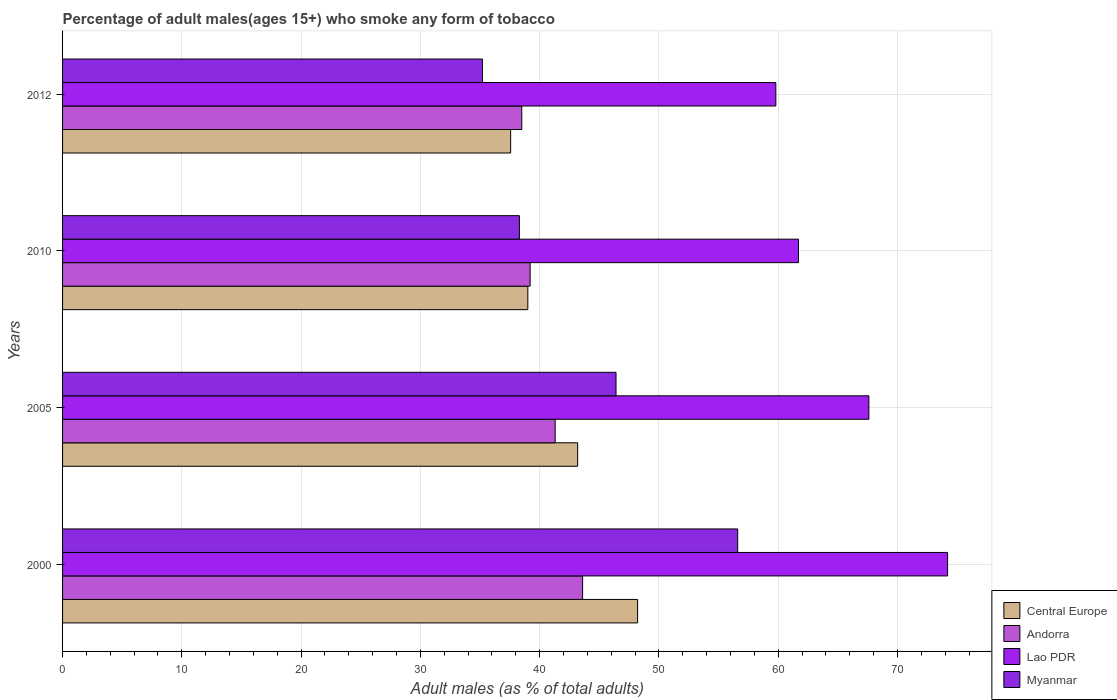How many different coloured bars are there?
Keep it short and to the point. 4. How many groups of bars are there?
Keep it short and to the point. 4. Are the number of bars per tick equal to the number of legend labels?
Offer a very short reply. Yes. How many bars are there on the 4th tick from the top?
Provide a succinct answer. 4. How many bars are there on the 1st tick from the bottom?
Offer a very short reply. 4. In how many cases, is the number of bars for a given year not equal to the number of legend labels?
Your response must be concise. 0. What is the percentage of adult males who smoke in Andorra in 2010?
Your response must be concise. 39.2. Across all years, what is the maximum percentage of adult males who smoke in Lao PDR?
Provide a succinct answer. 74.2. Across all years, what is the minimum percentage of adult males who smoke in Andorra?
Provide a succinct answer. 38.5. In which year was the percentage of adult males who smoke in Andorra minimum?
Provide a succinct answer. 2012. What is the total percentage of adult males who smoke in Central Europe in the graph?
Offer a very short reply. 167.97. What is the difference between the percentage of adult males who smoke in Central Europe in 2005 and that in 2010?
Your answer should be very brief. 4.18. What is the average percentage of adult males who smoke in Andorra per year?
Offer a terse response. 40.65. In the year 2012, what is the difference between the percentage of adult males who smoke in Myanmar and percentage of adult males who smoke in Lao PDR?
Keep it short and to the point. -24.6. In how many years, is the percentage of adult males who smoke in Andorra greater than 66 %?
Keep it short and to the point. 0. What is the ratio of the percentage of adult males who smoke in Lao PDR in 2000 to that in 2010?
Provide a succinct answer. 1.2. Is the percentage of adult males who smoke in Andorra in 2005 less than that in 2012?
Make the answer very short. No. What is the difference between the highest and the second highest percentage of adult males who smoke in Myanmar?
Your answer should be very brief. 10.2. What is the difference between the highest and the lowest percentage of adult males who smoke in Lao PDR?
Offer a terse response. 14.4. Is the sum of the percentage of adult males who smoke in Andorra in 2000 and 2005 greater than the maximum percentage of adult males who smoke in Myanmar across all years?
Make the answer very short. Yes. Is it the case that in every year, the sum of the percentage of adult males who smoke in Lao PDR and percentage of adult males who smoke in Myanmar is greater than the sum of percentage of adult males who smoke in Central Europe and percentage of adult males who smoke in Andorra?
Provide a short and direct response. No. What does the 2nd bar from the top in 2012 represents?
Give a very brief answer. Lao PDR. What does the 4th bar from the bottom in 2012 represents?
Offer a very short reply. Myanmar. Is it the case that in every year, the sum of the percentage of adult males who smoke in Myanmar and percentage of adult males who smoke in Lao PDR is greater than the percentage of adult males who smoke in Andorra?
Provide a short and direct response. Yes. Are all the bars in the graph horizontal?
Give a very brief answer. Yes. What is the difference between two consecutive major ticks on the X-axis?
Make the answer very short. 10. Are the values on the major ticks of X-axis written in scientific E-notation?
Offer a terse response. No. Does the graph contain grids?
Make the answer very short. Yes. What is the title of the graph?
Offer a very short reply. Percentage of adult males(ages 15+) who smoke any form of tobacco. What is the label or title of the X-axis?
Keep it short and to the point. Adult males (as % of total adults). What is the label or title of the Y-axis?
Your answer should be very brief. Years. What is the Adult males (as % of total adults) of Central Europe in 2000?
Make the answer very short. 48.21. What is the Adult males (as % of total adults) in Andorra in 2000?
Keep it short and to the point. 43.6. What is the Adult males (as % of total adults) of Lao PDR in 2000?
Your answer should be very brief. 74.2. What is the Adult males (as % of total adults) of Myanmar in 2000?
Provide a short and direct response. 56.6. What is the Adult males (as % of total adults) of Central Europe in 2005?
Your answer should be compact. 43.18. What is the Adult males (as % of total adults) in Andorra in 2005?
Make the answer very short. 41.3. What is the Adult males (as % of total adults) of Lao PDR in 2005?
Make the answer very short. 67.6. What is the Adult males (as % of total adults) in Myanmar in 2005?
Offer a very short reply. 46.4. What is the Adult males (as % of total adults) in Central Europe in 2010?
Keep it short and to the point. 39.01. What is the Adult males (as % of total adults) of Andorra in 2010?
Ensure brevity in your answer.  39.2. What is the Adult males (as % of total adults) in Lao PDR in 2010?
Ensure brevity in your answer.  61.7. What is the Adult males (as % of total adults) in Myanmar in 2010?
Make the answer very short. 38.3. What is the Adult males (as % of total adults) in Central Europe in 2012?
Ensure brevity in your answer.  37.57. What is the Adult males (as % of total adults) of Andorra in 2012?
Provide a short and direct response. 38.5. What is the Adult males (as % of total adults) of Lao PDR in 2012?
Offer a terse response. 59.8. What is the Adult males (as % of total adults) in Myanmar in 2012?
Give a very brief answer. 35.2. Across all years, what is the maximum Adult males (as % of total adults) in Central Europe?
Ensure brevity in your answer.  48.21. Across all years, what is the maximum Adult males (as % of total adults) of Andorra?
Offer a terse response. 43.6. Across all years, what is the maximum Adult males (as % of total adults) of Lao PDR?
Give a very brief answer. 74.2. Across all years, what is the maximum Adult males (as % of total adults) in Myanmar?
Give a very brief answer. 56.6. Across all years, what is the minimum Adult males (as % of total adults) in Central Europe?
Make the answer very short. 37.57. Across all years, what is the minimum Adult males (as % of total adults) of Andorra?
Your answer should be compact. 38.5. Across all years, what is the minimum Adult males (as % of total adults) of Lao PDR?
Make the answer very short. 59.8. Across all years, what is the minimum Adult males (as % of total adults) of Myanmar?
Give a very brief answer. 35.2. What is the total Adult males (as % of total adults) in Central Europe in the graph?
Your answer should be very brief. 167.97. What is the total Adult males (as % of total adults) in Andorra in the graph?
Give a very brief answer. 162.6. What is the total Adult males (as % of total adults) of Lao PDR in the graph?
Your answer should be compact. 263.3. What is the total Adult males (as % of total adults) in Myanmar in the graph?
Give a very brief answer. 176.5. What is the difference between the Adult males (as % of total adults) in Central Europe in 2000 and that in 2005?
Your answer should be very brief. 5.02. What is the difference between the Adult males (as % of total adults) in Andorra in 2000 and that in 2005?
Your answer should be compact. 2.3. What is the difference between the Adult males (as % of total adults) in Myanmar in 2000 and that in 2005?
Make the answer very short. 10.2. What is the difference between the Adult males (as % of total adults) in Central Europe in 2000 and that in 2010?
Offer a terse response. 9.2. What is the difference between the Adult males (as % of total adults) in Central Europe in 2000 and that in 2012?
Keep it short and to the point. 10.64. What is the difference between the Adult males (as % of total adults) of Myanmar in 2000 and that in 2012?
Provide a succinct answer. 21.4. What is the difference between the Adult males (as % of total adults) in Central Europe in 2005 and that in 2010?
Offer a very short reply. 4.18. What is the difference between the Adult males (as % of total adults) of Lao PDR in 2005 and that in 2010?
Offer a terse response. 5.9. What is the difference between the Adult males (as % of total adults) in Myanmar in 2005 and that in 2010?
Provide a short and direct response. 8.1. What is the difference between the Adult males (as % of total adults) of Central Europe in 2005 and that in 2012?
Your answer should be compact. 5.62. What is the difference between the Adult males (as % of total adults) in Andorra in 2005 and that in 2012?
Your answer should be very brief. 2.8. What is the difference between the Adult males (as % of total adults) of Central Europe in 2010 and that in 2012?
Ensure brevity in your answer.  1.44. What is the difference between the Adult males (as % of total adults) in Andorra in 2010 and that in 2012?
Your answer should be very brief. 0.7. What is the difference between the Adult males (as % of total adults) in Lao PDR in 2010 and that in 2012?
Give a very brief answer. 1.9. What is the difference between the Adult males (as % of total adults) in Central Europe in 2000 and the Adult males (as % of total adults) in Andorra in 2005?
Offer a very short reply. 6.91. What is the difference between the Adult males (as % of total adults) in Central Europe in 2000 and the Adult males (as % of total adults) in Lao PDR in 2005?
Make the answer very short. -19.39. What is the difference between the Adult males (as % of total adults) of Central Europe in 2000 and the Adult males (as % of total adults) of Myanmar in 2005?
Offer a terse response. 1.81. What is the difference between the Adult males (as % of total adults) in Andorra in 2000 and the Adult males (as % of total adults) in Lao PDR in 2005?
Ensure brevity in your answer.  -24. What is the difference between the Adult males (as % of total adults) of Andorra in 2000 and the Adult males (as % of total adults) of Myanmar in 2005?
Ensure brevity in your answer.  -2.8. What is the difference between the Adult males (as % of total adults) of Lao PDR in 2000 and the Adult males (as % of total adults) of Myanmar in 2005?
Your answer should be very brief. 27.8. What is the difference between the Adult males (as % of total adults) in Central Europe in 2000 and the Adult males (as % of total adults) in Andorra in 2010?
Provide a succinct answer. 9.01. What is the difference between the Adult males (as % of total adults) in Central Europe in 2000 and the Adult males (as % of total adults) in Lao PDR in 2010?
Offer a very short reply. -13.49. What is the difference between the Adult males (as % of total adults) in Central Europe in 2000 and the Adult males (as % of total adults) in Myanmar in 2010?
Your response must be concise. 9.91. What is the difference between the Adult males (as % of total adults) of Andorra in 2000 and the Adult males (as % of total adults) of Lao PDR in 2010?
Your answer should be very brief. -18.1. What is the difference between the Adult males (as % of total adults) in Lao PDR in 2000 and the Adult males (as % of total adults) in Myanmar in 2010?
Ensure brevity in your answer.  35.9. What is the difference between the Adult males (as % of total adults) in Central Europe in 2000 and the Adult males (as % of total adults) in Andorra in 2012?
Offer a terse response. 9.71. What is the difference between the Adult males (as % of total adults) in Central Europe in 2000 and the Adult males (as % of total adults) in Lao PDR in 2012?
Your answer should be compact. -11.59. What is the difference between the Adult males (as % of total adults) in Central Europe in 2000 and the Adult males (as % of total adults) in Myanmar in 2012?
Your answer should be compact. 13.01. What is the difference between the Adult males (as % of total adults) in Andorra in 2000 and the Adult males (as % of total adults) in Lao PDR in 2012?
Offer a terse response. -16.2. What is the difference between the Adult males (as % of total adults) of Andorra in 2000 and the Adult males (as % of total adults) of Myanmar in 2012?
Give a very brief answer. 8.4. What is the difference between the Adult males (as % of total adults) of Central Europe in 2005 and the Adult males (as % of total adults) of Andorra in 2010?
Your answer should be compact. 3.98. What is the difference between the Adult males (as % of total adults) in Central Europe in 2005 and the Adult males (as % of total adults) in Lao PDR in 2010?
Give a very brief answer. -18.52. What is the difference between the Adult males (as % of total adults) of Central Europe in 2005 and the Adult males (as % of total adults) of Myanmar in 2010?
Your response must be concise. 4.88. What is the difference between the Adult males (as % of total adults) of Andorra in 2005 and the Adult males (as % of total adults) of Lao PDR in 2010?
Ensure brevity in your answer.  -20.4. What is the difference between the Adult males (as % of total adults) in Andorra in 2005 and the Adult males (as % of total adults) in Myanmar in 2010?
Your answer should be compact. 3. What is the difference between the Adult males (as % of total adults) of Lao PDR in 2005 and the Adult males (as % of total adults) of Myanmar in 2010?
Provide a succinct answer. 29.3. What is the difference between the Adult males (as % of total adults) of Central Europe in 2005 and the Adult males (as % of total adults) of Andorra in 2012?
Make the answer very short. 4.68. What is the difference between the Adult males (as % of total adults) of Central Europe in 2005 and the Adult males (as % of total adults) of Lao PDR in 2012?
Give a very brief answer. -16.62. What is the difference between the Adult males (as % of total adults) in Central Europe in 2005 and the Adult males (as % of total adults) in Myanmar in 2012?
Give a very brief answer. 7.98. What is the difference between the Adult males (as % of total adults) of Andorra in 2005 and the Adult males (as % of total adults) of Lao PDR in 2012?
Keep it short and to the point. -18.5. What is the difference between the Adult males (as % of total adults) in Andorra in 2005 and the Adult males (as % of total adults) in Myanmar in 2012?
Provide a short and direct response. 6.1. What is the difference between the Adult males (as % of total adults) in Lao PDR in 2005 and the Adult males (as % of total adults) in Myanmar in 2012?
Offer a very short reply. 32.4. What is the difference between the Adult males (as % of total adults) of Central Europe in 2010 and the Adult males (as % of total adults) of Andorra in 2012?
Your answer should be compact. 0.51. What is the difference between the Adult males (as % of total adults) in Central Europe in 2010 and the Adult males (as % of total adults) in Lao PDR in 2012?
Ensure brevity in your answer.  -20.79. What is the difference between the Adult males (as % of total adults) in Central Europe in 2010 and the Adult males (as % of total adults) in Myanmar in 2012?
Your response must be concise. 3.81. What is the difference between the Adult males (as % of total adults) in Andorra in 2010 and the Adult males (as % of total adults) in Lao PDR in 2012?
Offer a very short reply. -20.6. What is the difference between the Adult males (as % of total adults) of Lao PDR in 2010 and the Adult males (as % of total adults) of Myanmar in 2012?
Keep it short and to the point. 26.5. What is the average Adult males (as % of total adults) in Central Europe per year?
Your answer should be compact. 41.99. What is the average Adult males (as % of total adults) of Andorra per year?
Your answer should be compact. 40.65. What is the average Adult males (as % of total adults) of Lao PDR per year?
Your answer should be very brief. 65.83. What is the average Adult males (as % of total adults) in Myanmar per year?
Offer a very short reply. 44.12. In the year 2000, what is the difference between the Adult males (as % of total adults) in Central Europe and Adult males (as % of total adults) in Andorra?
Keep it short and to the point. 4.61. In the year 2000, what is the difference between the Adult males (as % of total adults) of Central Europe and Adult males (as % of total adults) of Lao PDR?
Keep it short and to the point. -25.99. In the year 2000, what is the difference between the Adult males (as % of total adults) in Central Europe and Adult males (as % of total adults) in Myanmar?
Ensure brevity in your answer.  -8.39. In the year 2000, what is the difference between the Adult males (as % of total adults) in Andorra and Adult males (as % of total adults) in Lao PDR?
Offer a terse response. -30.6. In the year 2000, what is the difference between the Adult males (as % of total adults) in Andorra and Adult males (as % of total adults) in Myanmar?
Provide a short and direct response. -13. In the year 2005, what is the difference between the Adult males (as % of total adults) of Central Europe and Adult males (as % of total adults) of Andorra?
Give a very brief answer. 1.88. In the year 2005, what is the difference between the Adult males (as % of total adults) in Central Europe and Adult males (as % of total adults) in Lao PDR?
Offer a very short reply. -24.42. In the year 2005, what is the difference between the Adult males (as % of total adults) of Central Europe and Adult males (as % of total adults) of Myanmar?
Offer a very short reply. -3.22. In the year 2005, what is the difference between the Adult males (as % of total adults) of Andorra and Adult males (as % of total adults) of Lao PDR?
Provide a succinct answer. -26.3. In the year 2005, what is the difference between the Adult males (as % of total adults) of Andorra and Adult males (as % of total adults) of Myanmar?
Your response must be concise. -5.1. In the year 2005, what is the difference between the Adult males (as % of total adults) in Lao PDR and Adult males (as % of total adults) in Myanmar?
Make the answer very short. 21.2. In the year 2010, what is the difference between the Adult males (as % of total adults) in Central Europe and Adult males (as % of total adults) in Andorra?
Offer a terse response. -0.19. In the year 2010, what is the difference between the Adult males (as % of total adults) of Central Europe and Adult males (as % of total adults) of Lao PDR?
Offer a terse response. -22.69. In the year 2010, what is the difference between the Adult males (as % of total adults) of Central Europe and Adult males (as % of total adults) of Myanmar?
Your answer should be compact. 0.71. In the year 2010, what is the difference between the Adult males (as % of total adults) of Andorra and Adult males (as % of total adults) of Lao PDR?
Give a very brief answer. -22.5. In the year 2010, what is the difference between the Adult males (as % of total adults) in Lao PDR and Adult males (as % of total adults) in Myanmar?
Ensure brevity in your answer.  23.4. In the year 2012, what is the difference between the Adult males (as % of total adults) in Central Europe and Adult males (as % of total adults) in Andorra?
Ensure brevity in your answer.  -0.93. In the year 2012, what is the difference between the Adult males (as % of total adults) in Central Europe and Adult males (as % of total adults) in Lao PDR?
Make the answer very short. -22.23. In the year 2012, what is the difference between the Adult males (as % of total adults) in Central Europe and Adult males (as % of total adults) in Myanmar?
Give a very brief answer. 2.37. In the year 2012, what is the difference between the Adult males (as % of total adults) in Andorra and Adult males (as % of total adults) in Lao PDR?
Your answer should be compact. -21.3. In the year 2012, what is the difference between the Adult males (as % of total adults) in Andorra and Adult males (as % of total adults) in Myanmar?
Ensure brevity in your answer.  3.3. In the year 2012, what is the difference between the Adult males (as % of total adults) of Lao PDR and Adult males (as % of total adults) of Myanmar?
Make the answer very short. 24.6. What is the ratio of the Adult males (as % of total adults) of Central Europe in 2000 to that in 2005?
Offer a terse response. 1.12. What is the ratio of the Adult males (as % of total adults) of Andorra in 2000 to that in 2005?
Provide a short and direct response. 1.06. What is the ratio of the Adult males (as % of total adults) in Lao PDR in 2000 to that in 2005?
Your answer should be compact. 1.1. What is the ratio of the Adult males (as % of total adults) in Myanmar in 2000 to that in 2005?
Offer a very short reply. 1.22. What is the ratio of the Adult males (as % of total adults) of Central Europe in 2000 to that in 2010?
Offer a terse response. 1.24. What is the ratio of the Adult males (as % of total adults) of Andorra in 2000 to that in 2010?
Give a very brief answer. 1.11. What is the ratio of the Adult males (as % of total adults) of Lao PDR in 2000 to that in 2010?
Your answer should be very brief. 1.2. What is the ratio of the Adult males (as % of total adults) of Myanmar in 2000 to that in 2010?
Your answer should be compact. 1.48. What is the ratio of the Adult males (as % of total adults) of Central Europe in 2000 to that in 2012?
Your answer should be very brief. 1.28. What is the ratio of the Adult males (as % of total adults) in Andorra in 2000 to that in 2012?
Make the answer very short. 1.13. What is the ratio of the Adult males (as % of total adults) in Lao PDR in 2000 to that in 2012?
Offer a terse response. 1.24. What is the ratio of the Adult males (as % of total adults) of Myanmar in 2000 to that in 2012?
Make the answer very short. 1.61. What is the ratio of the Adult males (as % of total adults) in Central Europe in 2005 to that in 2010?
Provide a succinct answer. 1.11. What is the ratio of the Adult males (as % of total adults) in Andorra in 2005 to that in 2010?
Ensure brevity in your answer.  1.05. What is the ratio of the Adult males (as % of total adults) of Lao PDR in 2005 to that in 2010?
Provide a short and direct response. 1.1. What is the ratio of the Adult males (as % of total adults) in Myanmar in 2005 to that in 2010?
Offer a terse response. 1.21. What is the ratio of the Adult males (as % of total adults) of Central Europe in 2005 to that in 2012?
Provide a succinct answer. 1.15. What is the ratio of the Adult males (as % of total adults) of Andorra in 2005 to that in 2012?
Your response must be concise. 1.07. What is the ratio of the Adult males (as % of total adults) of Lao PDR in 2005 to that in 2012?
Keep it short and to the point. 1.13. What is the ratio of the Adult males (as % of total adults) of Myanmar in 2005 to that in 2012?
Give a very brief answer. 1.32. What is the ratio of the Adult males (as % of total adults) in Central Europe in 2010 to that in 2012?
Your response must be concise. 1.04. What is the ratio of the Adult males (as % of total adults) in Andorra in 2010 to that in 2012?
Give a very brief answer. 1.02. What is the ratio of the Adult males (as % of total adults) of Lao PDR in 2010 to that in 2012?
Offer a very short reply. 1.03. What is the ratio of the Adult males (as % of total adults) of Myanmar in 2010 to that in 2012?
Make the answer very short. 1.09. What is the difference between the highest and the second highest Adult males (as % of total adults) of Central Europe?
Offer a very short reply. 5.02. What is the difference between the highest and the second highest Adult males (as % of total adults) of Lao PDR?
Make the answer very short. 6.6. What is the difference between the highest and the lowest Adult males (as % of total adults) in Central Europe?
Your answer should be very brief. 10.64. What is the difference between the highest and the lowest Adult males (as % of total adults) in Lao PDR?
Keep it short and to the point. 14.4. What is the difference between the highest and the lowest Adult males (as % of total adults) of Myanmar?
Ensure brevity in your answer.  21.4. 